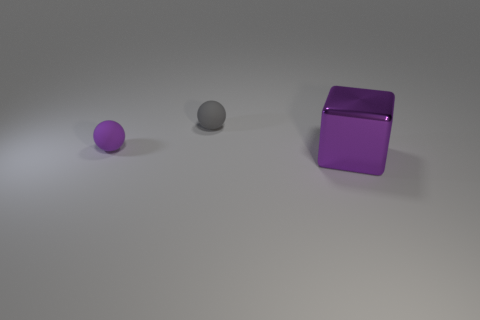Add 3 gray spheres. How many objects exist? 6 Subtract all blue cylinders. How many gray balls are left? 1 Subtract all rubber spheres. Subtract all cubes. How many objects are left? 0 Add 2 big metal cubes. How many big metal cubes are left? 3 Add 1 tiny matte objects. How many tiny matte objects exist? 3 Subtract 0 blue cubes. How many objects are left? 3 Subtract all cubes. How many objects are left? 2 Subtract 1 spheres. How many spheres are left? 1 Subtract all green balls. Subtract all blue cylinders. How many balls are left? 2 